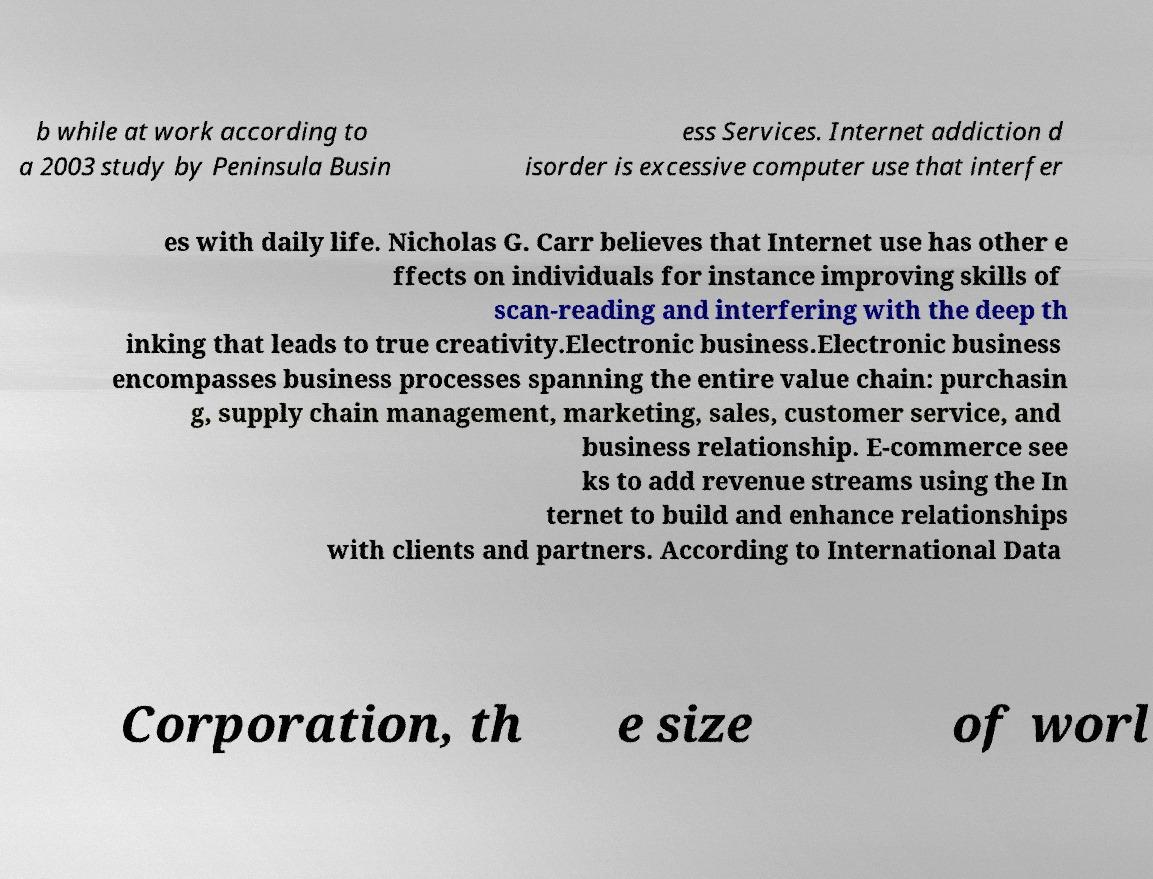Please identify and transcribe the text found in this image. b while at work according to a 2003 study by Peninsula Busin ess Services. Internet addiction d isorder is excessive computer use that interfer es with daily life. Nicholas G. Carr believes that Internet use has other e ffects on individuals for instance improving skills of scan-reading and interfering with the deep th inking that leads to true creativity.Electronic business.Electronic business encompasses business processes spanning the entire value chain: purchasin g, supply chain management, marketing, sales, customer service, and business relationship. E-commerce see ks to add revenue streams using the In ternet to build and enhance relationships with clients and partners. According to International Data Corporation, th e size of worl 